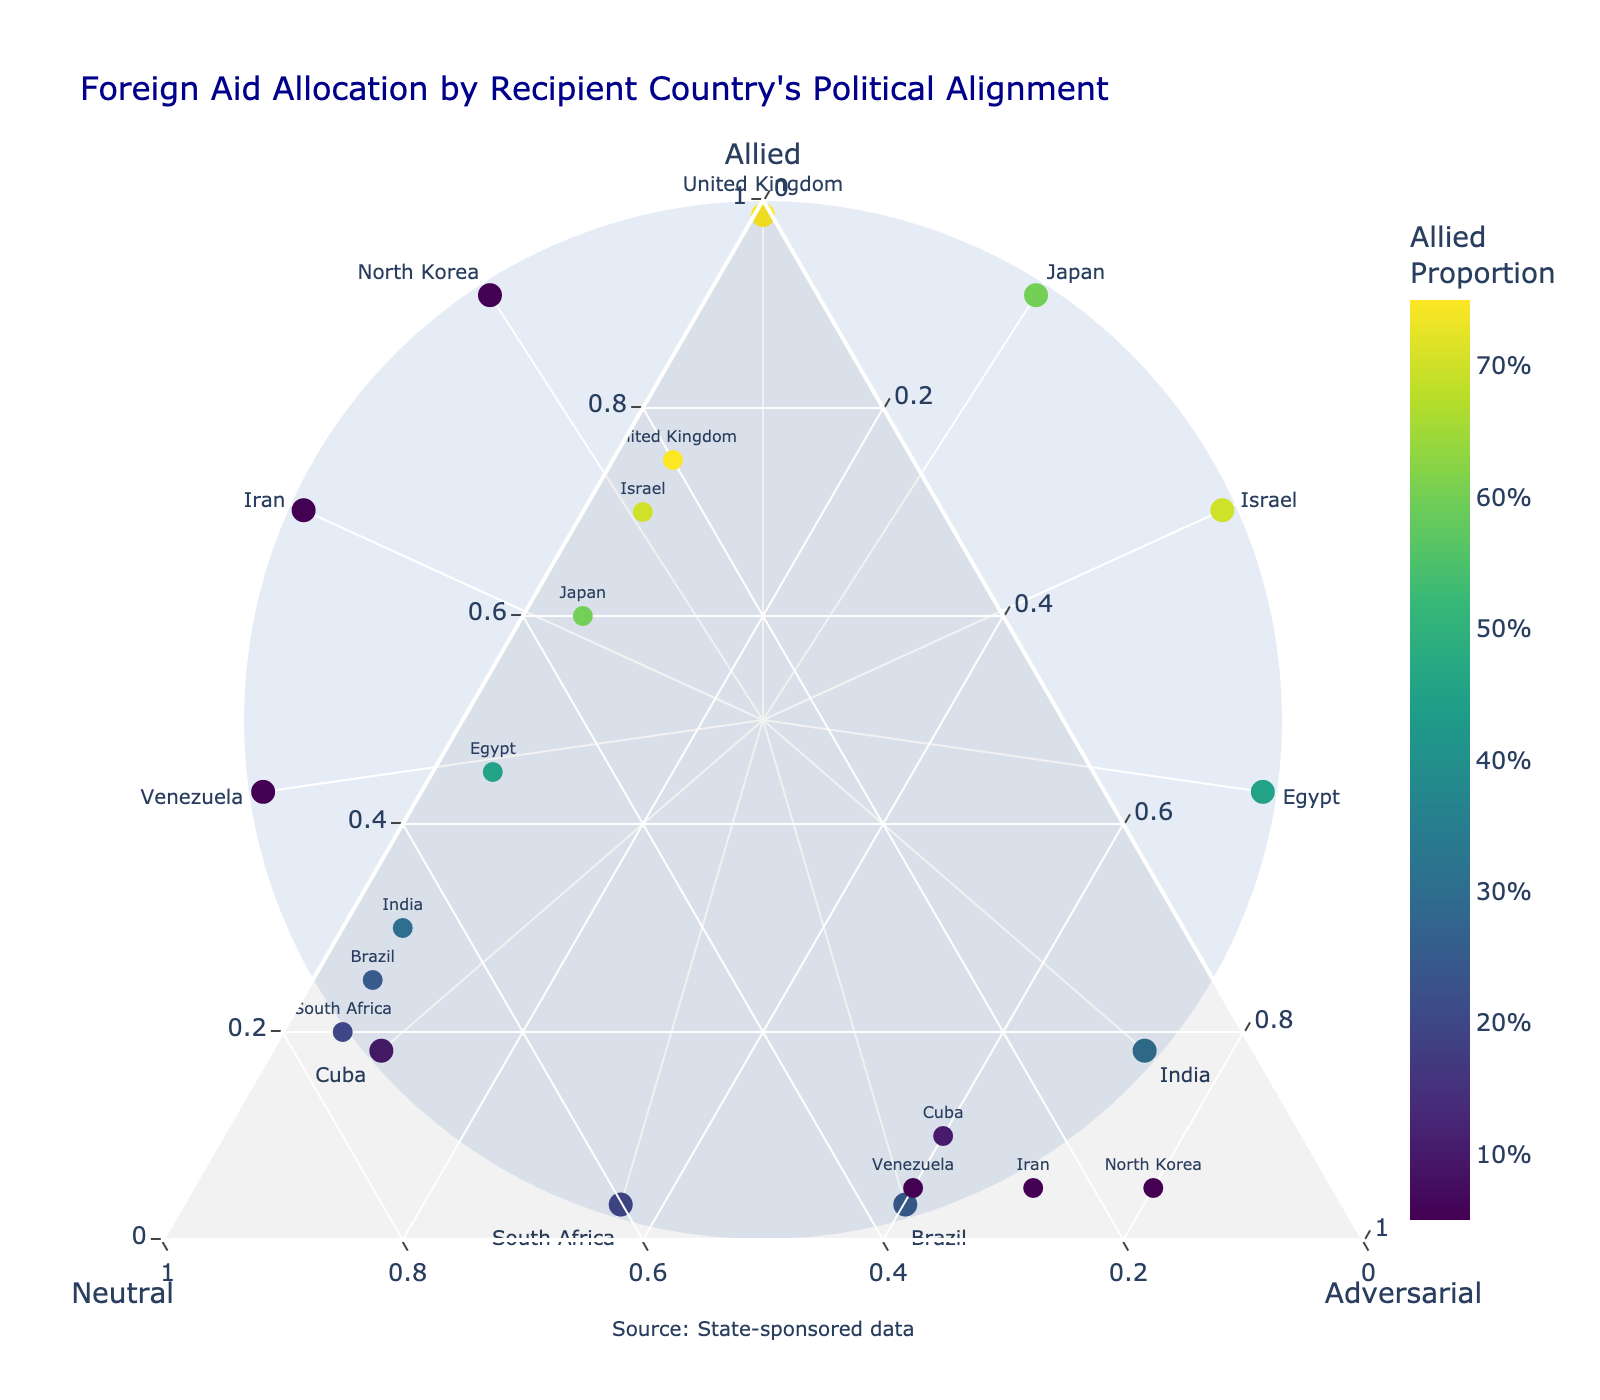What is the title of the plot? The title is usually located at the top of the plot. It summarizes what the figure represents. In this case, the title is "Foreign Aid Allocation by Recipient Country's Political Alignment".
Answer: Foreign Aid Allocation by Recipient Country's Political Alignment How many countries are represented in the plot? To determine the number of countries represented, count the distinct country labels in the plot. There are 11 countries listed in the provided data.
Answer: 11 Which country has the highest proportion of aid classified as 'Adversarial'? Look for the data point positioned closest to the 'Adversarial' vertex of the ternary plot. North Korea has the highest value at 0.80.
Answer: North Korea What proportion of aid does Egypt receive as 'Neutral'? Examine the position of Egypt on the ternary plot or refer to the hover text for Egypt. The proportion of aid classified as 'Neutral' for Egypt is 0.50.
Answer: 0.50 Which country receives an equal amount of aid from both 'Allied' and 'Neutral' categories? Investigate the plot for a country that is positioned along the line equidistant from both 'Allied' and 'Neutral' vertices. Egypt has roughly equal proportions of 'Allied' and 'Neutral' aid, both around 0.45 and 0.50 respectively.
Answer: Egypt Is there a country that receives less than 10% of aid as 'Adversarial'? Examine each data point's position on the ternary plot for the 'Adversarial' scale and identify countries below 0.10 in this category. The United Kingdom, Japan, Israel, Egypt, India, Brazil, and South Africa all fall into this category.
Answer: Yes Among the 'Allied' and 'Neutral', which category does Brazil receive the most aid from? Compare the allied and neutral proportions directly for Brazil from the plot or hover text. Brazil receives more aid classified as 'Neutral' at 0.70 compared to 0.25 for 'Allied'.
Answer: Neutral Which country has at least 60% of its foreign aid classified as 'Allied'? Identify data points close to the 'Allied' vertex. The United Kingdom, Japan, and Israel all receive at least 60% of their aid classified as 'Allied'.
Answer: United Kingdom, Japan, Israel How does the political alignment distribution of Venezuela compare to that of Iran? For a thorough comparison, examine the ternary plot for both countries. Venezuela has 0.05 'Allied', 0.35 'Neutral', and 0.60 'Adversarial'. Iran has 0.05 'Allied', 0.25 'Neutral', and 0.70 'Adversarial'. Thus, Iran receives more 'Adversarial' aid than Venezuela, while Venezuela gets more 'Neutral' aid.
Answer: Venezuela: More 'Neutral', Iran: More 'Adversarial' What is the average proportion of 'Adversarial' aid across all countries? Sum all the 'Adversarial' values and divide by the number of countries. The sum is (0.05 + 0.05 + 0.05 + 0.05 + 0.05 + 0.05 + 0.05 + 0.60 + 0.60 + 0.70 + 0.80) = 3.80. The average is 3.80/11 = 0.345.
Answer: 0.345 